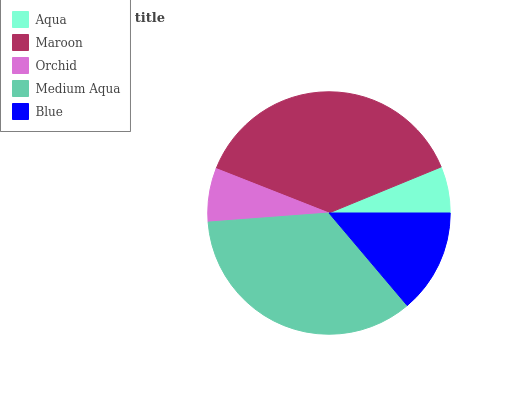Is Aqua the minimum?
Answer yes or no. Yes. Is Maroon the maximum?
Answer yes or no. Yes. Is Orchid the minimum?
Answer yes or no. No. Is Orchid the maximum?
Answer yes or no. No. Is Maroon greater than Orchid?
Answer yes or no. Yes. Is Orchid less than Maroon?
Answer yes or no. Yes. Is Orchid greater than Maroon?
Answer yes or no. No. Is Maroon less than Orchid?
Answer yes or no. No. Is Blue the high median?
Answer yes or no. Yes. Is Blue the low median?
Answer yes or no. Yes. Is Maroon the high median?
Answer yes or no. No. Is Orchid the low median?
Answer yes or no. No. 